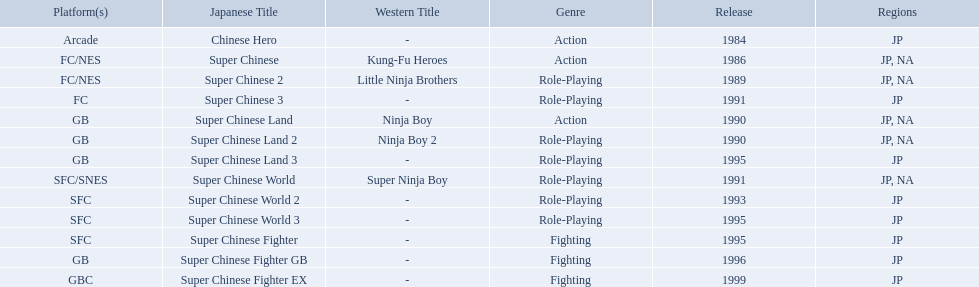Super ninja world was released in what countries? JP, NA. What was the original name for this title? Super Chinese World. 